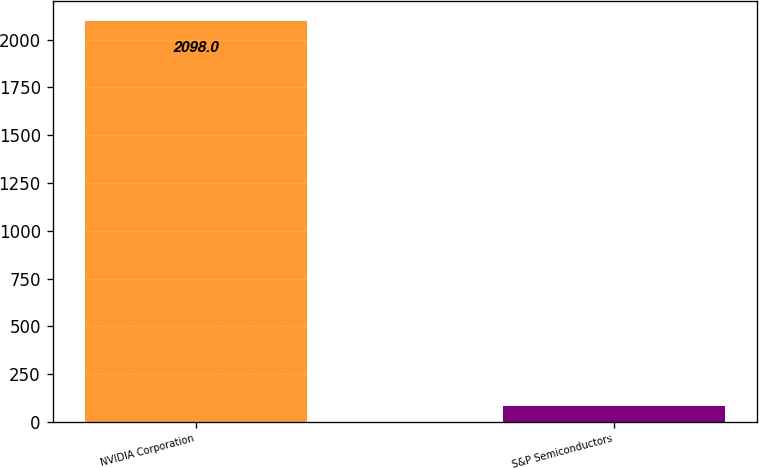Convert chart to OTSL. <chart><loc_0><loc_0><loc_500><loc_500><bar_chart><fcel>NVIDIA Corporation<fcel>S&P Semiconductors<nl><fcel>2098<fcel>81.43<nl></chart> 